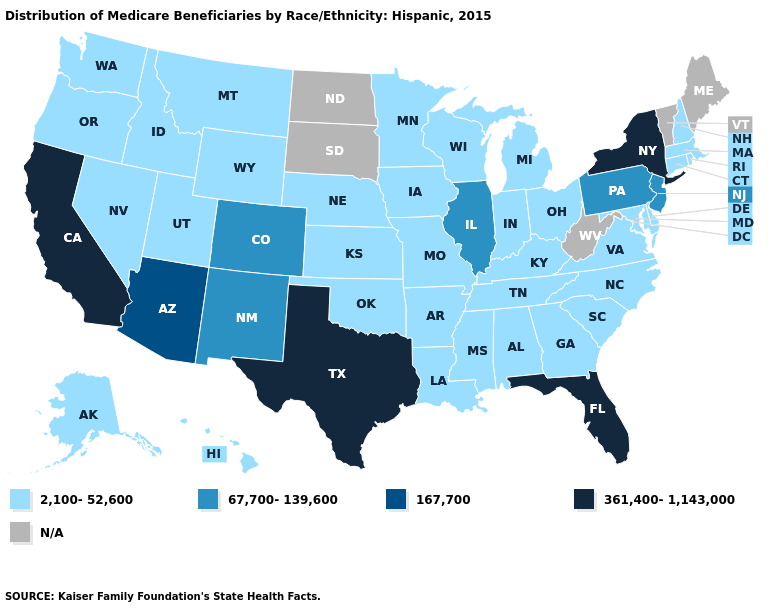Name the states that have a value in the range 361,400-1,143,000?
Concise answer only. California, Florida, New York, Texas. Name the states that have a value in the range 361,400-1,143,000?
Keep it brief. California, Florida, New York, Texas. What is the value of Oregon?
Write a very short answer. 2,100-52,600. Name the states that have a value in the range 2,100-52,600?
Concise answer only. Alabama, Alaska, Arkansas, Connecticut, Delaware, Georgia, Hawaii, Idaho, Indiana, Iowa, Kansas, Kentucky, Louisiana, Maryland, Massachusetts, Michigan, Minnesota, Mississippi, Missouri, Montana, Nebraska, Nevada, New Hampshire, North Carolina, Ohio, Oklahoma, Oregon, Rhode Island, South Carolina, Tennessee, Utah, Virginia, Washington, Wisconsin, Wyoming. What is the value of Massachusetts?
Keep it brief. 2,100-52,600. What is the highest value in the USA?
Keep it brief. 361,400-1,143,000. What is the lowest value in the USA?
Keep it brief. 2,100-52,600. Does Texas have the highest value in the South?
Be succinct. Yes. What is the highest value in states that border Maryland?
Concise answer only. 67,700-139,600. What is the value of West Virginia?
Quick response, please. N/A. What is the highest value in states that border Missouri?
Write a very short answer. 67,700-139,600. Which states have the lowest value in the Northeast?
Concise answer only. Connecticut, Massachusetts, New Hampshire, Rhode Island. Name the states that have a value in the range N/A?
Be succinct. Maine, North Dakota, South Dakota, Vermont, West Virginia. 